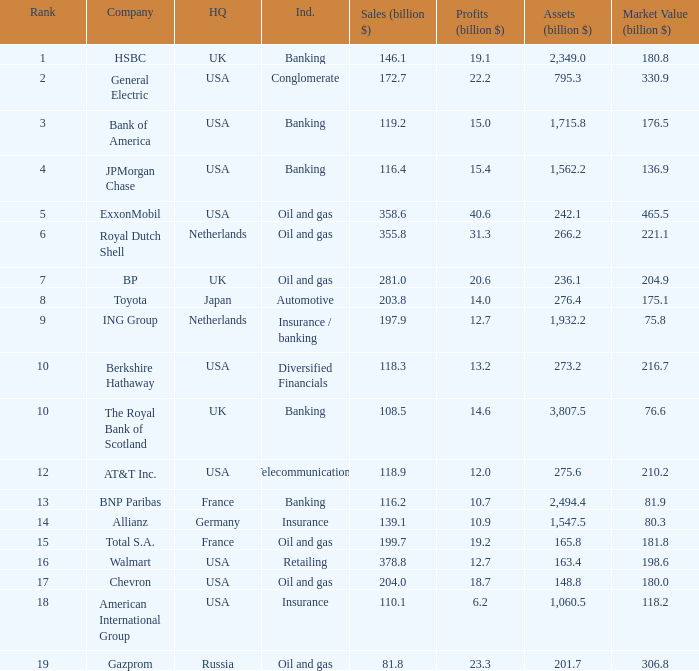What are the profits in billions for Berkshire Hathaway?  13.2. 